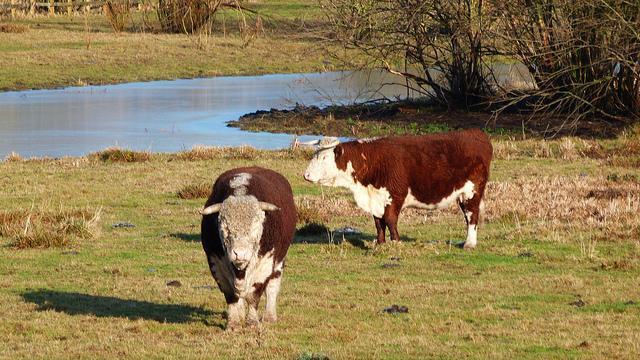How many cattle are in the scene?
Give a very brief answer. 2. How many animals are depicted?
Give a very brief answer. 2. How many cows can be seen?
Give a very brief answer. 2. 